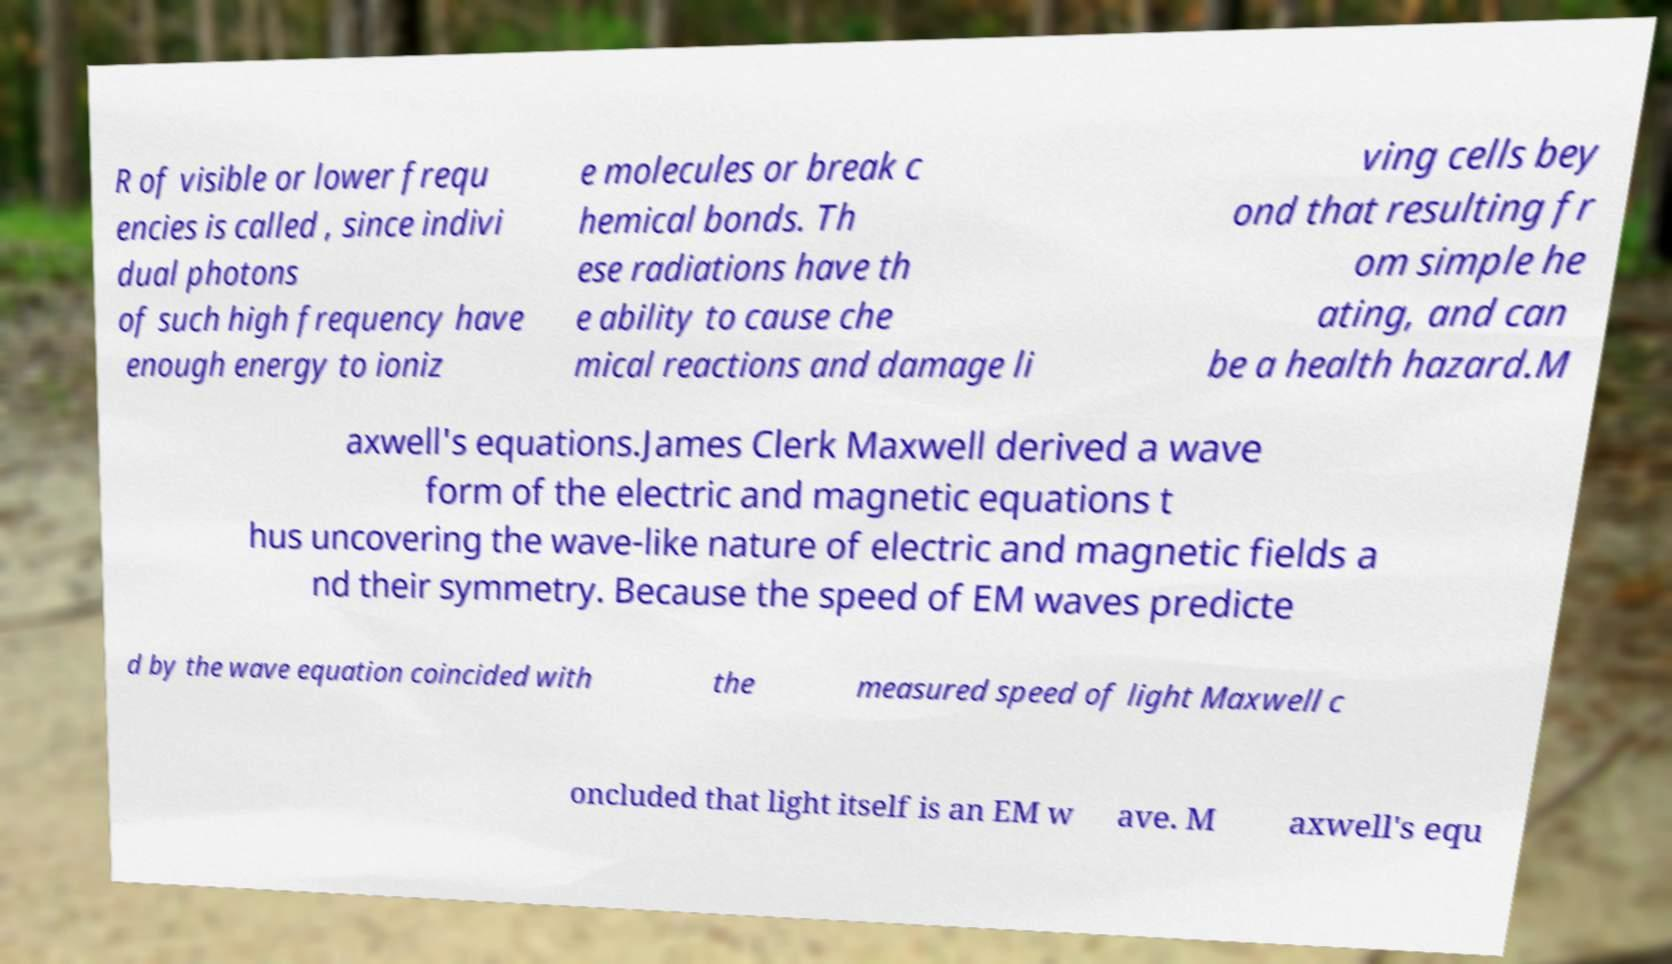What messages or text are displayed in this image? I need them in a readable, typed format. R of visible or lower frequ encies is called , since indivi dual photons of such high frequency have enough energy to ioniz e molecules or break c hemical bonds. Th ese radiations have th e ability to cause che mical reactions and damage li ving cells bey ond that resulting fr om simple he ating, and can be a health hazard.M axwell's equations.James Clerk Maxwell derived a wave form of the electric and magnetic equations t hus uncovering the wave-like nature of electric and magnetic fields a nd their symmetry. Because the speed of EM waves predicte d by the wave equation coincided with the measured speed of light Maxwell c oncluded that light itself is an EM w ave. M axwell's equ 